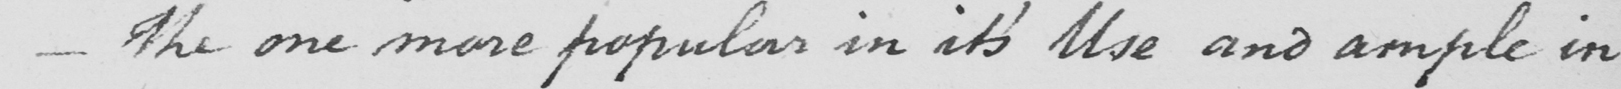Transcribe the text shown in this historical manuscript line. _  The one more popular in it ' s Use and ample in 